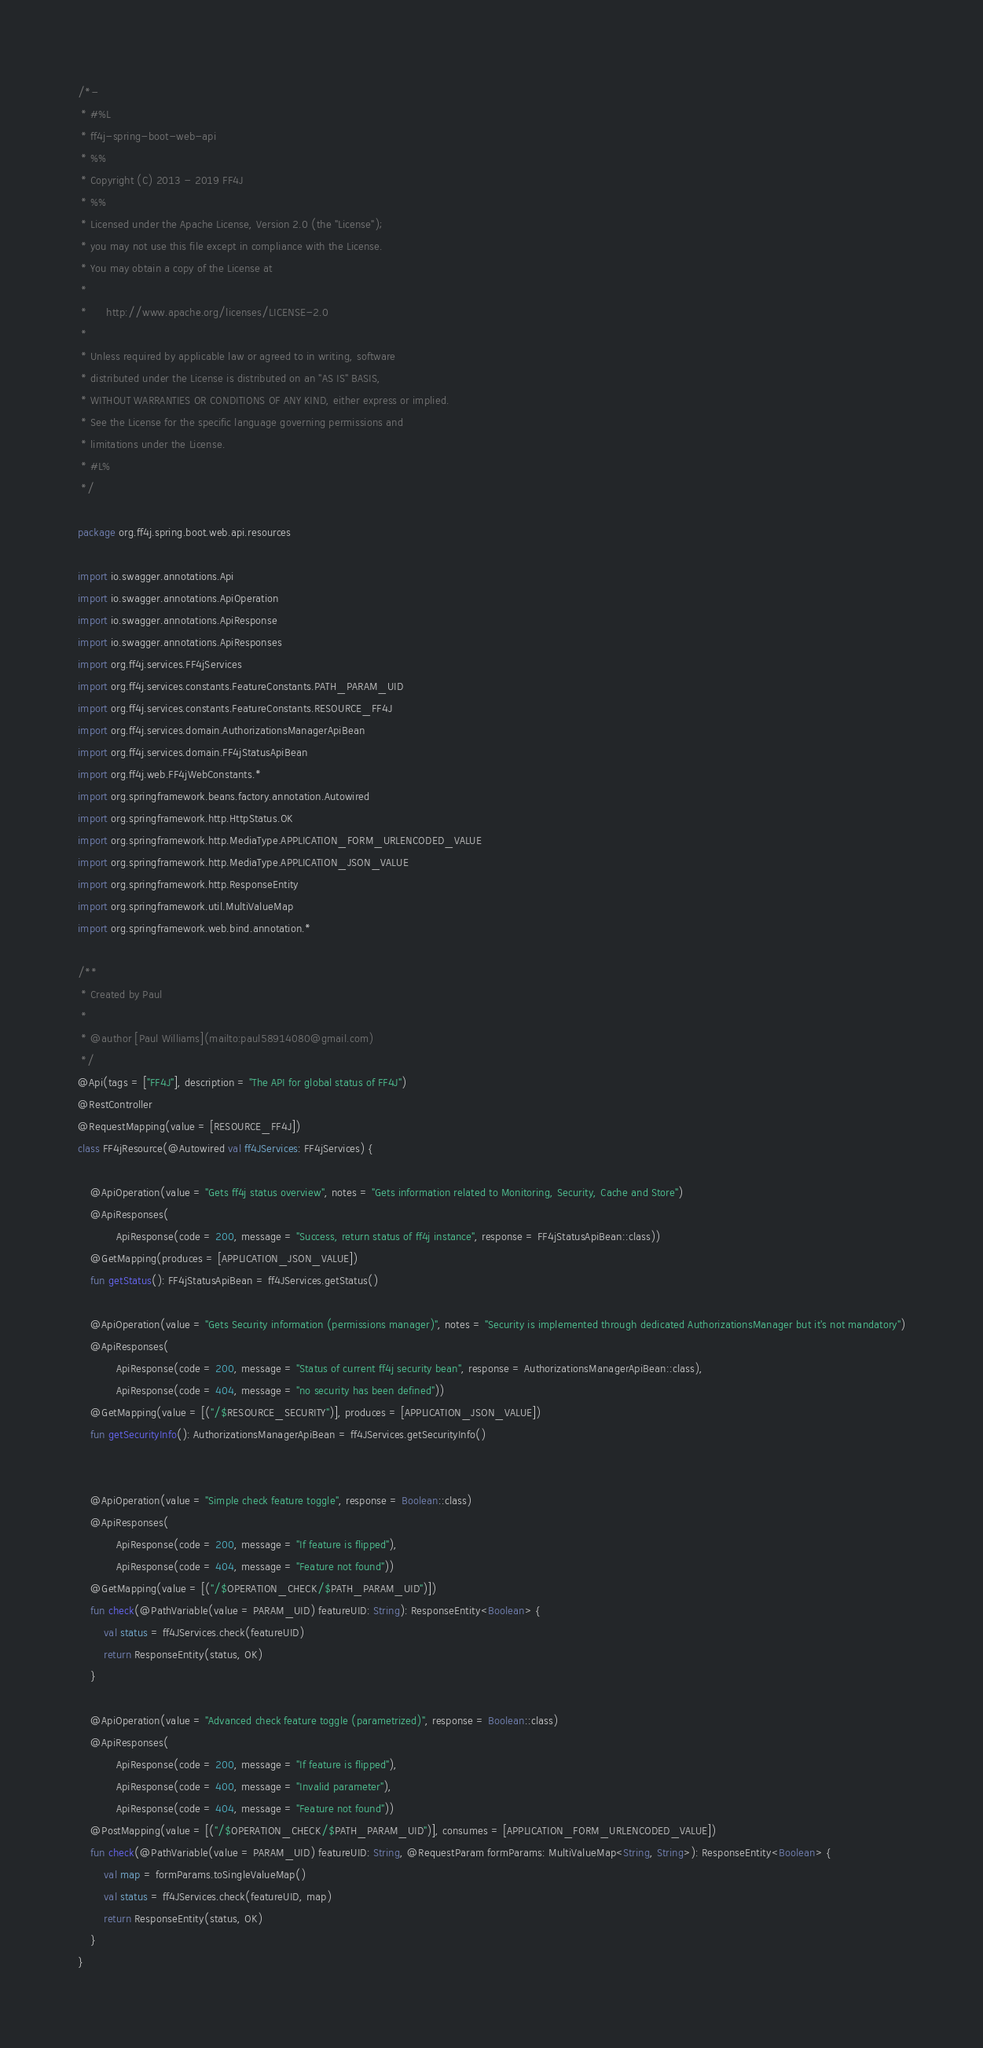<code> <loc_0><loc_0><loc_500><loc_500><_Kotlin_>/*-
 * #%L
 * ff4j-spring-boot-web-api
 * %%
 * Copyright (C) 2013 - 2019 FF4J
 * %%
 * Licensed under the Apache License, Version 2.0 (the "License");
 * you may not use this file except in compliance with the License.
 * You may obtain a copy of the License at
 * 
 *      http://www.apache.org/licenses/LICENSE-2.0
 * 
 * Unless required by applicable law or agreed to in writing, software
 * distributed under the License is distributed on an "AS IS" BASIS,
 * WITHOUT WARRANTIES OR CONDITIONS OF ANY KIND, either express or implied.
 * See the License for the specific language governing permissions and
 * limitations under the License.
 * #L%
 */

package org.ff4j.spring.boot.web.api.resources

import io.swagger.annotations.Api
import io.swagger.annotations.ApiOperation
import io.swagger.annotations.ApiResponse
import io.swagger.annotations.ApiResponses
import org.ff4j.services.FF4jServices
import org.ff4j.services.constants.FeatureConstants.PATH_PARAM_UID
import org.ff4j.services.constants.FeatureConstants.RESOURCE_FF4J
import org.ff4j.services.domain.AuthorizationsManagerApiBean
import org.ff4j.services.domain.FF4jStatusApiBean
import org.ff4j.web.FF4jWebConstants.*
import org.springframework.beans.factory.annotation.Autowired
import org.springframework.http.HttpStatus.OK
import org.springframework.http.MediaType.APPLICATION_FORM_URLENCODED_VALUE
import org.springframework.http.MediaType.APPLICATION_JSON_VALUE
import org.springframework.http.ResponseEntity
import org.springframework.util.MultiValueMap
import org.springframework.web.bind.annotation.*

/**
 * Created by Paul
 *
 * @author [Paul Williams](mailto:paul58914080@gmail.com)
 */
@Api(tags = ["FF4J"], description = "The API for global status of FF4J")
@RestController
@RequestMapping(value = [RESOURCE_FF4J])
class FF4jResource(@Autowired val ff4JServices: FF4jServices) {

    @ApiOperation(value = "Gets ff4j status overview", notes = "Gets information related to Monitoring, Security, Cache and Store")
    @ApiResponses(
            ApiResponse(code = 200, message = "Success, return status of ff4j instance", response = FF4jStatusApiBean::class))
    @GetMapping(produces = [APPLICATION_JSON_VALUE])
    fun getStatus(): FF4jStatusApiBean = ff4JServices.getStatus()

    @ApiOperation(value = "Gets Security information (permissions manager)", notes = "Security is implemented through dedicated AuthorizationsManager but it's not mandatory")
    @ApiResponses(
            ApiResponse(code = 200, message = "Status of current ff4j security bean", response = AuthorizationsManagerApiBean::class),
            ApiResponse(code = 404, message = "no security has been defined"))
    @GetMapping(value = [("/$RESOURCE_SECURITY")], produces = [APPLICATION_JSON_VALUE])
    fun getSecurityInfo(): AuthorizationsManagerApiBean = ff4JServices.getSecurityInfo()


    @ApiOperation(value = "Simple check feature toggle", response = Boolean::class)
    @ApiResponses(
            ApiResponse(code = 200, message = "If feature is flipped"),
            ApiResponse(code = 404, message = "Feature not found"))
    @GetMapping(value = [("/$OPERATION_CHECK/$PATH_PARAM_UID")])
    fun check(@PathVariable(value = PARAM_UID) featureUID: String): ResponseEntity<Boolean> {
        val status = ff4JServices.check(featureUID)
        return ResponseEntity(status, OK)
    }

    @ApiOperation(value = "Advanced check feature toggle (parametrized)", response = Boolean::class)
    @ApiResponses(
            ApiResponse(code = 200, message = "If feature is flipped"),
            ApiResponse(code = 400, message = "Invalid parameter"),
            ApiResponse(code = 404, message = "Feature not found"))
    @PostMapping(value = [("/$OPERATION_CHECK/$PATH_PARAM_UID")], consumes = [APPLICATION_FORM_URLENCODED_VALUE])
    fun check(@PathVariable(value = PARAM_UID) featureUID: String, @RequestParam formParams: MultiValueMap<String, String>): ResponseEntity<Boolean> {
        val map = formParams.toSingleValueMap()
        val status = ff4JServices.check(featureUID, map)
        return ResponseEntity(status, OK)
    }
}
</code> 